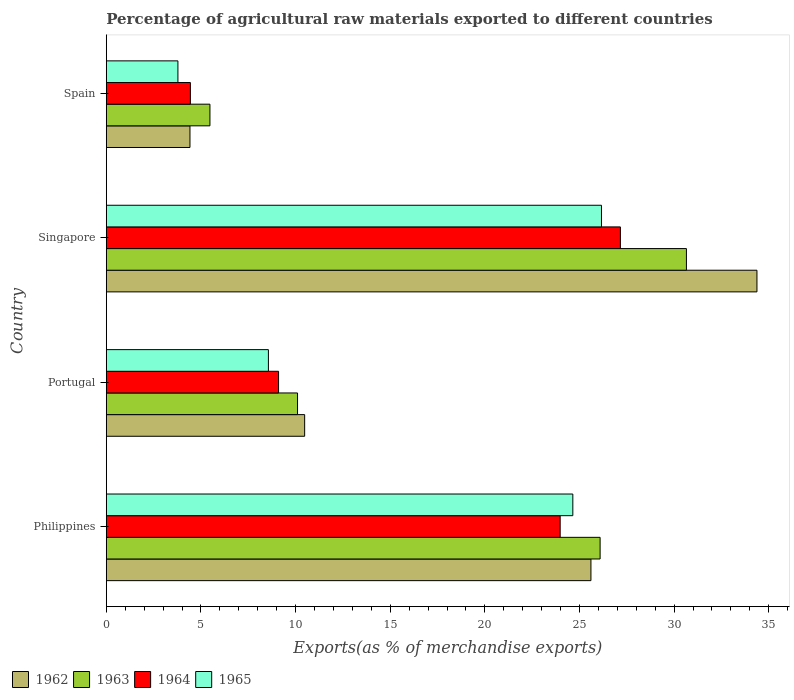How many groups of bars are there?
Ensure brevity in your answer.  4. Are the number of bars per tick equal to the number of legend labels?
Offer a very short reply. Yes. How many bars are there on the 4th tick from the bottom?
Provide a succinct answer. 4. In how many cases, is the number of bars for a given country not equal to the number of legend labels?
Offer a very short reply. 0. What is the percentage of exports to different countries in 1964 in Singapore?
Ensure brevity in your answer.  27.16. Across all countries, what is the maximum percentage of exports to different countries in 1963?
Offer a terse response. 30.65. Across all countries, what is the minimum percentage of exports to different countries in 1963?
Your response must be concise. 5.47. In which country was the percentage of exports to different countries in 1965 maximum?
Offer a terse response. Singapore. What is the total percentage of exports to different countries in 1965 in the graph?
Provide a succinct answer. 63.15. What is the difference between the percentage of exports to different countries in 1964 in Portugal and that in Singapore?
Your answer should be compact. -18.06. What is the difference between the percentage of exports to different countries in 1963 in Spain and the percentage of exports to different countries in 1965 in Philippines?
Offer a very short reply. -19.17. What is the average percentage of exports to different countries in 1962 per country?
Keep it short and to the point. 18.72. What is the difference between the percentage of exports to different countries in 1963 and percentage of exports to different countries in 1964 in Spain?
Your answer should be compact. 1.03. In how many countries, is the percentage of exports to different countries in 1963 greater than 17 %?
Keep it short and to the point. 2. What is the ratio of the percentage of exports to different countries in 1963 in Singapore to that in Spain?
Your response must be concise. 5.6. Is the percentage of exports to different countries in 1964 in Singapore less than that in Spain?
Provide a short and direct response. No. Is the difference between the percentage of exports to different countries in 1963 in Philippines and Spain greater than the difference between the percentage of exports to different countries in 1964 in Philippines and Spain?
Offer a very short reply. Yes. What is the difference between the highest and the second highest percentage of exports to different countries in 1964?
Keep it short and to the point. 3.18. What is the difference between the highest and the lowest percentage of exports to different countries in 1964?
Ensure brevity in your answer.  22.72. In how many countries, is the percentage of exports to different countries in 1964 greater than the average percentage of exports to different countries in 1964 taken over all countries?
Ensure brevity in your answer.  2. Is the sum of the percentage of exports to different countries in 1964 in Singapore and Spain greater than the maximum percentage of exports to different countries in 1965 across all countries?
Provide a short and direct response. Yes. Is it the case that in every country, the sum of the percentage of exports to different countries in 1964 and percentage of exports to different countries in 1963 is greater than the sum of percentage of exports to different countries in 1965 and percentage of exports to different countries in 1962?
Your answer should be compact. No. What does the 2nd bar from the top in Spain represents?
Make the answer very short. 1964. What does the 3rd bar from the bottom in Singapore represents?
Keep it short and to the point. 1964. How many bars are there?
Make the answer very short. 16. Are all the bars in the graph horizontal?
Give a very brief answer. Yes. How many countries are there in the graph?
Offer a terse response. 4. Does the graph contain any zero values?
Offer a terse response. No. Where does the legend appear in the graph?
Offer a terse response. Bottom left. How many legend labels are there?
Your response must be concise. 4. How are the legend labels stacked?
Your answer should be compact. Horizontal. What is the title of the graph?
Make the answer very short. Percentage of agricultural raw materials exported to different countries. Does "2014" appear as one of the legend labels in the graph?
Offer a terse response. No. What is the label or title of the X-axis?
Offer a very short reply. Exports(as % of merchandise exports). What is the label or title of the Y-axis?
Provide a short and direct response. Country. What is the Exports(as % of merchandise exports) of 1962 in Philippines?
Your answer should be compact. 25.6. What is the Exports(as % of merchandise exports) in 1963 in Philippines?
Your response must be concise. 26.09. What is the Exports(as % of merchandise exports) in 1964 in Philippines?
Your answer should be compact. 23.98. What is the Exports(as % of merchandise exports) of 1965 in Philippines?
Your response must be concise. 24.65. What is the Exports(as % of merchandise exports) in 1962 in Portugal?
Offer a terse response. 10.48. What is the Exports(as % of merchandise exports) of 1963 in Portugal?
Provide a succinct answer. 10.1. What is the Exports(as % of merchandise exports) of 1964 in Portugal?
Give a very brief answer. 9.1. What is the Exports(as % of merchandise exports) of 1965 in Portugal?
Provide a succinct answer. 8.56. What is the Exports(as % of merchandise exports) of 1962 in Singapore?
Ensure brevity in your answer.  34.38. What is the Exports(as % of merchandise exports) in 1963 in Singapore?
Offer a terse response. 30.65. What is the Exports(as % of merchandise exports) of 1964 in Singapore?
Provide a short and direct response. 27.16. What is the Exports(as % of merchandise exports) of 1965 in Singapore?
Make the answer very short. 26.16. What is the Exports(as % of merchandise exports) of 1962 in Spain?
Your response must be concise. 4.42. What is the Exports(as % of merchandise exports) in 1963 in Spain?
Ensure brevity in your answer.  5.47. What is the Exports(as % of merchandise exports) of 1964 in Spain?
Your answer should be very brief. 4.44. What is the Exports(as % of merchandise exports) of 1965 in Spain?
Your answer should be compact. 3.78. Across all countries, what is the maximum Exports(as % of merchandise exports) in 1962?
Give a very brief answer. 34.38. Across all countries, what is the maximum Exports(as % of merchandise exports) of 1963?
Give a very brief answer. 30.65. Across all countries, what is the maximum Exports(as % of merchandise exports) in 1964?
Keep it short and to the point. 27.16. Across all countries, what is the maximum Exports(as % of merchandise exports) in 1965?
Keep it short and to the point. 26.16. Across all countries, what is the minimum Exports(as % of merchandise exports) of 1962?
Your answer should be very brief. 4.42. Across all countries, what is the minimum Exports(as % of merchandise exports) in 1963?
Your response must be concise. 5.47. Across all countries, what is the minimum Exports(as % of merchandise exports) of 1964?
Offer a very short reply. 4.44. Across all countries, what is the minimum Exports(as % of merchandise exports) in 1965?
Make the answer very short. 3.78. What is the total Exports(as % of merchandise exports) of 1962 in the graph?
Your answer should be very brief. 74.88. What is the total Exports(as % of merchandise exports) of 1963 in the graph?
Offer a terse response. 72.31. What is the total Exports(as % of merchandise exports) in 1964 in the graph?
Offer a terse response. 64.68. What is the total Exports(as % of merchandise exports) of 1965 in the graph?
Offer a very short reply. 63.15. What is the difference between the Exports(as % of merchandise exports) of 1962 in Philippines and that in Portugal?
Offer a very short reply. 15.13. What is the difference between the Exports(as % of merchandise exports) in 1963 in Philippines and that in Portugal?
Offer a very short reply. 15.99. What is the difference between the Exports(as % of merchandise exports) in 1964 in Philippines and that in Portugal?
Your answer should be very brief. 14.88. What is the difference between the Exports(as % of merchandise exports) in 1965 in Philippines and that in Portugal?
Your response must be concise. 16.08. What is the difference between the Exports(as % of merchandise exports) in 1962 in Philippines and that in Singapore?
Offer a terse response. -8.77. What is the difference between the Exports(as % of merchandise exports) in 1963 in Philippines and that in Singapore?
Your answer should be compact. -4.56. What is the difference between the Exports(as % of merchandise exports) of 1964 in Philippines and that in Singapore?
Keep it short and to the point. -3.18. What is the difference between the Exports(as % of merchandise exports) in 1965 in Philippines and that in Singapore?
Give a very brief answer. -1.51. What is the difference between the Exports(as % of merchandise exports) of 1962 in Philippines and that in Spain?
Ensure brevity in your answer.  21.19. What is the difference between the Exports(as % of merchandise exports) of 1963 in Philippines and that in Spain?
Your answer should be very brief. 20.62. What is the difference between the Exports(as % of merchandise exports) of 1964 in Philippines and that in Spain?
Your answer should be very brief. 19.54. What is the difference between the Exports(as % of merchandise exports) of 1965 in Philippines and that in Spain?
Give a very brief answer. 20.86. What is the difference between the Exports(as % of merchandise exports) in 1962 in Portugal and that in Singapore?
Provide a succinct answer. -23.9. What is the difference between the Exports(as % of merchandise exports) in 1963 in Portugal and that in Singapore?
Your answer should be very brief. -20.55. What is the difference between the Exports(as % of merchandise exports) in 1964 in Portugal and that in Singapore?
Your answer should be compact. -18.06. What is the difference between the Exports(as % of merchandise exports) in 1965 in Portugal and that in Singapore?
Provide a succinct answer. -17.6. What is the difference between the Exports(as % of merchandise exports) in 1962 in Portugal and that in Spain?
Your response must be concise. 6.06. What is the difference between the Exports(as % of merchandise exports) in 1963 in Portugal and that in Spain?
Give a very brief answer. 4.63. What is the difference between the Exports(as % of merchandise exports) in 1964 in Portugal and that in Spain?
Ensure brevity in your answer.  4.66. What is the difference between the Exports(as % of merchandise exports) in 1965 in Portugal and that in Spain?
Provide a short and direct response. 4.78. What is the difference between the Exports(as % of merchandise exports) in 1962 in Singapore and that in Spain?
Make the answer very short. 29.96. What is the difference between the Exports(as % of merchandise exports) in 1963 in Singapore and that in Spain?
Ensure brevity in your answer.  25.18. What is the difference between the Exports(as % of merchandise exports) of 1964 in Singapore and that in Spain?
Give a very brief answer. 22.72. What is the difference between the Exports(as % of merchandise exports) in 1965 in Singapore and that in Spain?
Keep it short and to the point. 22.38. What is the difference between the Exports(as % of merchandise exports) of 1962 in Philippines and the Exports(as % of merchandise exports) of 1963 in Portugal?
Your answer should be very brief. 15.5. What is the difference between the Exports(as % of merchandise exports) in 1962 in Philippines and the Exports(as % of merchandise exports) in 1964 in Portugal?
Your answer should be very brief. 16.5. What is the difference between the Exports(as % of merchandise exports) of 1962 in Philippines and the Exports(as % of merchandise exports) of 1965 in Portugal?
Your answer should be very brief. 17.04. What is the difference between the Exports(as % of merchandise exports) in 1963 in Philippines and the Exports(as % of merchandise exports) in 1964 in Portugal?
Your response must be concise. 16.99. What is the difference between the Exports(as % of merchandise exports) of 1963 in Philippines and the Exports(as % of merchandise exports) of 1965 in Portugal?
Your answer should be very brief. 17.53. What is the difference between the Exports(as % of merchandise exports) of 1964 in Philippines and the Exports(as % of merchandise exports) of 1965 in Portugal?
Your answer should be very brief. 15.42. What is the difference between the Exports(as % of merchandise exports) of 1962 in Philippines and the Exports(as % of merchandise exports) of 1963 in Singapore?
Your answer should be very brief. -5.04. What is the difference between the Exports(as % of merchandise exports) of 1962 in Philippines and the Exports(as % of merchandise exports) of 1964 in Singapore?
Offer a terse response. -1.56. What is the difference between the Exports(as % of merchandise exports) of 1962 in Philippines and the Exports(as % of merchandise exports) of 1965 in Singapore?
Your answer should be compact. -0.56. What is the difference between the Exports(as % of merchandise exports) of 1963 in Philippines and the Exports(as % of merchandise exports) of 1964 in Singapore?
Your response must be concise. -1.07. What is the difference between the Exports(as % of merchandise exports) of 1963 in Philippines and the Exports(as % of merchandise exports) of 1965 in Singapore?
Provide a succinct answer. -0.07. What is the difference between the Exports(as % of merchandise exports) of 1964 in Philippines and the Exports(as % of merchandise exports) of 1965 in Singapore?
Offer a very short reply. -2.18. What is the difference between the Exports(as % of merchandise exports) of 1962 in Philippines and the Exports(as % of merchandise exports) of 1963 in Spain?
Your answer should be compact. 20.13. What is the difference between the Exports(as % of merchandise exports) in 1962 in Philippines and the Exports(as % of merchandise exports) in 1964 in Spain?
Offer a very short reply. 21.16. What is the difference between the Exports(as % of merchandise exports) of 1962 in Philippines and the Exports(as % of merchandise exports) of 1965 in Spain?
Your answer should be compact. 21.82. What is the difference between the Exports(as % of merchandise exports) in 1963 in Philippines and the Exports(as % of merchandise exports) in 1964 in Spain?
Your response must be concise. 21.65. What is the difference between the Exports(as % of merchandise exports) of 1963 in Philippines and the Exports(as % of merchandise exports) of 1965 in Spain?
Provide a short and direct response. 22.31. What is the difference between the Exports(as % of merchandise exports) of 1964 in Philippines and the Exports(as % of merchandise exports) of 1965 in Spain?
Your answer should be compact. 20.2. What is the difference between the Exports(as % of merchandise exports) in 1962 in Portugal and the Exports(as % of merchandise exports) in 1963 in Singapore?
Offer a very short reply. -20.17. What is the difference between the Exports(as % of merchandise exports) of 1962 in Portugal and the Exports(as % of merchandise exports) of 1964 in Singapore?
Keep it short and to the point. -16.68. What is the difference between the Exports(as % of merchandise exports) of 1962 in Portugal and the Exports(as % of merchandise exports) of 1965 in Singapore?
Your response must be concise. -15.68. What is the difference between the Exports(as % of merchandise exports) of 1963 in Portugal and the Exports(as % of merchandise exports) of 1964 in Singapore?
Ensure brevity in your answer.  -17.06. What is the difference between the Exports(as % of merchandise exports) of 1963 in Portugal and the Exports(as % of merchandise exports) of 1965 in Singapore?
Offer a terse response. -16.06. What is the difference between the Exports(as % of merchandise exports) in 1964 in Portugal and the Exports(as % of merchandise exports) in 1965 in Singapore?
Your answer should be very brief. -17.06. What is the difference between the Exports(as % of merchandise exports) in 1962 in Portugal and the Exports(as % of merchandise exports) in 1963 in Spain?
Offer a very short reply. 5. What is the difference between the Exports(as % of merchandise exports) in 1962 in Portugal and the Exports(as % of merchandise exports) in 1964 in Spain?
Offer a very short reply. 6.04. What is the difference between the Exports(as % of merchandise exports) in 1962 in Portugal and the Exports(as % of merchandise exports) in 1965 in Spain?
Ensure brevity in your answer.  6.7. What is the difference between the Exports(as % of merchandise exports) in 1963 in Portugal and the Exports(as % of merchandise exports) in 1964 in Spain?
Offer a terse response. 5.66. What is the difference between the Exports(as % of merchandise exports) in 1963 in Portugal and the Exports(as % of merchandise exports) in 1965 in Spain?
Offer a very short reply. 6.32. What is the difference between the Exports(as % of merchandise exports) in 1964 in Portugal and the Exports(as % of merchandise exports) in 1965 in Spain?
Offer a very short reply. 5.32. What is the difference between the Exports(as % of merchandise exports) of 1962 in Singapore and the Exports(as % of merchandise exports) of 1963 in Spain?
Provide a succinct answer. 28.9. What is the difference between the Exports(as % of merchandise exports) of 1962 in Singapore and the Exports(as % of merchandise exports) of 1964 in Spain?
Keep it short and to the point. 29.94. What is the difference between the Exports(as % of merchandise exports) in 1962 in Singapore and the Exports(as % of merchandise exports) in 1965 in Spain?
Make the answer very short. 30.59. What is the difference between the Exports(as % of merchandise exports) in 1963 in Singapore and the Exports(as % of merchandise exports) in 1964 in Spain?
Your response must be concise. 26.21. What is the difference between the Exports(as % of merchandise exports) in 1963 in Singapore and the Exports(as % of merchandise exports) in 1965 in Spain?
Your answer should be very brief. 26.87. What is the difference between the Exports(as % of merchandise exports) of 1964 in Singapore and the Exports(as % of merchandise exports) of 1965 in Spain?
Your answer should be very brief. 23.38. What is the average Exports(as % of merchandise exports) of 1962 per country?
Make the answer very short. 18.72. What is the average Exports(as % of merchandise exports) in 1963 per country?
Ensure brevity in your answer.  18.08. What is the average Exports(as % of merchandise exports) in 1964 per country?
Offer a very short reply. 16.17. What is the average Exports(as % of merchandise exports) of 1965 per country?
Make the answer very short. 15.79. What is the difference between the Exports(as % of merchandise exports) of 1962 and Exports(as % of merchandise exports) of 1963 in Philippines?
Offer a terse response. -0.49. What is the difference between the Exports(as % of merchandise exports) in 1962 and Exports(as % of merchandise exports) in 1964 in Philippines?
Keep it short and to the point. 1.63. What is the difference between the Exports(as % of merchandise exports) of 1962 and Exports(as % of merchandise exports) of 1965 in Philippines?
Your answer should be very brief. 0.96. What is the difference between the Exports(as % of merchandise exports) of 1963 and Exports(as % of merchandise exports) of 1964 in Philippines?
Give a very brief answer. 2.11. What is the difference between the Exports(as % of merchandise exports) in 1963 and Exports(as % of merchandise exports) in 1965 in Philippines?
Keep it short and to the point. 1.44. What is the difference between the Exports(as % of merchandise exports) of 1964 and Exports(as % of merchandise exports) of 1965 in Philippines?
Offer a terse response. -0.67. What is the difference between the Exports(as % of merchandise exports) in 1962 and Exports(as % of merchandise exports) in 1963 in Portugal?
Your answer should be compact. 0.38. What is the difference between the Exports(as % of merchandise exports) of 1962 and Exports(as % of merchandise exports) of 1964 in Portugal?
Provide a short and direct response. 1.38. What is the difference between the Exports(as % of merchandise exports) of 1962 and Exports(as % of merchandise exports) of 1965 in Portugal?
Give a very brief answer. 1.92. What is the difference between the Exports(as % of merchandise exports) in 1963 and Exports(as % of merchandise exports) in 1964 in Portugal?
Provide a succinct answer. 1. What is the difference between the Exports(as % of merchandise exports) of 1963 and Exports(as % of merchandise exports) of 1965 in Portugal?
Make the answer very short. 1.54. What is the difference between the Exports(as % of merchandise exports) of 1964 and Exports(as % of merchandise exports) of 1965 in Portugal?
Provide a succinct answer. 0.54. What is the difference between the Exports(as % of merchandise exports) in 1962 and Exports(as % of merchandise exports) in 1963 in Singapore?
Offer a terse response. 3.73. What is the difference between the Exports(as % of merchandise exports) in 1962 and Exports(as % of merchandise exports) in 1964 in Singapore?
Offer a terse response. 7.22. What is the difference between the Exports(as % of merchandise exports) in 1962 and Exports(as % of merchandise exports) in 1965 in Singapore?
Make the answer very short. 8.22. What is the difference between the Exports(as % of merchandise exports) in 1963 and Exports(as % of merchandise exports) in 1964 in Singapore?
Your response must be concise. 3.49. What is the difference between the Exports(as % of merchandise exports) in 1963 and Exports(as % of merchandise exports) in 1965 in Singapore?
Your response must be concise. 4.49. What is the difference between the Exports(as % of merchandise exports) in 1964 and Exports(as % of merchandise exports) in 1965 in Singapore?
Your response must be concise. 1. What is the difference between the Exports(as % of merchandise exports) in 1962 and Exports(as % of merchandise exports) in 1963 in Spain?
Keep it short and to the point. -1.06. What is the difference between the Exports(as % of merchandise exports) in 1962 and Exports(as % of merchandise exports) in 1964 in Spain?
Your response must be concise. -0.02. What is the difference between the Exports(as % of merchandise exports) of 1962 and Exports(as % of merchandise exports) of 1965 in Spain?
Your answer should be compact. 0.64. What is the difference between the Exports(as % of merchandise exports) in 1963 and Exports(as % of merchandise exports) in 1964 in Spain?
Your response must be concise. 1.03. What is the difference between the Exports(as % of merchandise exports) in 1963 and Exports(as % of merchandise exports) in 1965 in Spain?
Offer a very short reply. 1.69. What is the difference between the Exports(as % of merchandise exports) in 1964 and Exports(as % of merchandise exports) in 1965 in Spain?
Provide a short and direct response. 0.66. What is the ratio of the Exports(as % of merchandise exports) of 1962 in Philippines to that in Portugal?
Offer a very short reply. 2.44. What is the ratio of the Exports(as % of merchandise exports) in 1963 in Philippines to that in Portugal?
Provide a short and direct response. 2.58. What is the ratio of the Exports(as % of merchandise exports) of 1964 in Philippines to that in Portugal?
Provide a succinct answer. 2.64. What is the ratio of the Exports(as % of merchandise exports) of 1965 in Philippines to that in Portugal?
Your answer should be compact. 2.88. What is the ratio of the Exports(as % of merchandise exports) of 1962 in Philippines to that in Singapore?
Provide a short and direct response. 0.74. What is the ratio of the Exports(as % of merchandise exports) in 1963 in Philippines to that in Singapore?
Keep it short and to the point. 0.85. What is the ratio of the Exports(as % of merchandise exports) in 1964 in Philippines to that in Singapore?
Make the answer very short. 0.88. What is the ratio of the Exports(as % of merchandise exports) in 1965 in Philippines to that in Singapore?
Give a very brief answer. 0.94. What is the ratio of the Exports(as % of merchandise exports) in 1962 in Philippines to that in Spain?
Provide a short and direct response. 5.79. What is the ratio of the Exports(as % of merchandise exports) of 1963 in Philippines to that in Spain?
Offer a very short reply. 4.77. What is the ratio of the Exports(as % of merchandise exports) of 1964 in Philippines to that in Spain?
Provide a succinct answer. 5.4. What is the ratio of the Exports(as % of merchandise exports) in 1965 in Philippines to that in Spain?
Your answer should be compact. 6.52. What is the ratio of the Exports(as % of merchandise exports) in 1962 in Portugal to that in Singapore?
Provide a short and direct response. 0.3. What is the ratio of the Exports(as % of merchandise exports) of 1963 in Portugal to that in Singapore?
Give a very brief answer. 0.33. What is the ratio of the Exports(as % of merchandise exports) in 1964 in Portugal to that in Singapore?
Offer a very short reply. 0.34. What is the ratio of the Exports(as % of merchandise exports) of 1965 in Portugal to that in Singapore?
Offer a terse response. 0.33. What is the ratio of the Exports(as % of merchandise exports) of 1962 in Portugal to that in Spain?
Keep it short and to the point. 2.37. What is the ratio of the Exports(as % of merchandise exports) in 1963 in Portugal to that in Spain?
Your response must be concise. 1.85. What is the ratio of the Exports(as % of merchandise exports) of 1964 in Portugal to that in Spain?
Offer a terse response. 2.05. What is the ratio of the Exports(as % of merchandise exports) of 1965 in Portugal to that in Spain?
Offer a very short reply. 2.26. What is the ratio of the Exports(as % of merchandise exports) in 1962 in Singapore to that in Spain?
Offer a very short reply. 7.78. What is the ratio of the Exports(as % of merchandise exports) of 1963 in Singapore to that in Spain?
Offer a very short reply. 5.6. What is the ratio of the Exports(as % of merchandise exports) of 1964 in Singapore to that in Spain?
Give a very brief answer. 6.12. What is the ratio of the Exports(as % of merchandise exports) in 1965 in Singapore to that in Spain?
Provide a succinct answer. 6.92. What is the difference between the highest and the second highest Exports(as % of merchandise exports) in 1962?
Provide a succinct answer. 8.77. What is the difference between the highest and the second highest Exports(as % of merchandise exports) in 1963?
Give a very brief answer. 4.56. What is the difference between the highest and the second highest Exports(as % of merchandise exports) in 1964?
Make the answer very short. 3.18. What is the difference between the highest and the second highest Exports(as % of merchandise exports) of 1965?
Offer a very short reply. 1.51. What is the difference between the highest and the lowest Exports(as % of merchandise exports) in 1962?
Offer a very short reply. 29.96. What is the difference between the highest and the lowest Exports(as % of merchandise exports) in 1963?
Offer a terse response. 25.18. What is the difference between the highest and the lowest Exports(as % of merchandise exports) of 1964?
Your response must be concise. 22.72. What is the difference between the highest and the lowest Exports(as % of merchandise exports) in 1965?
Your response must be concise. 22.38. 